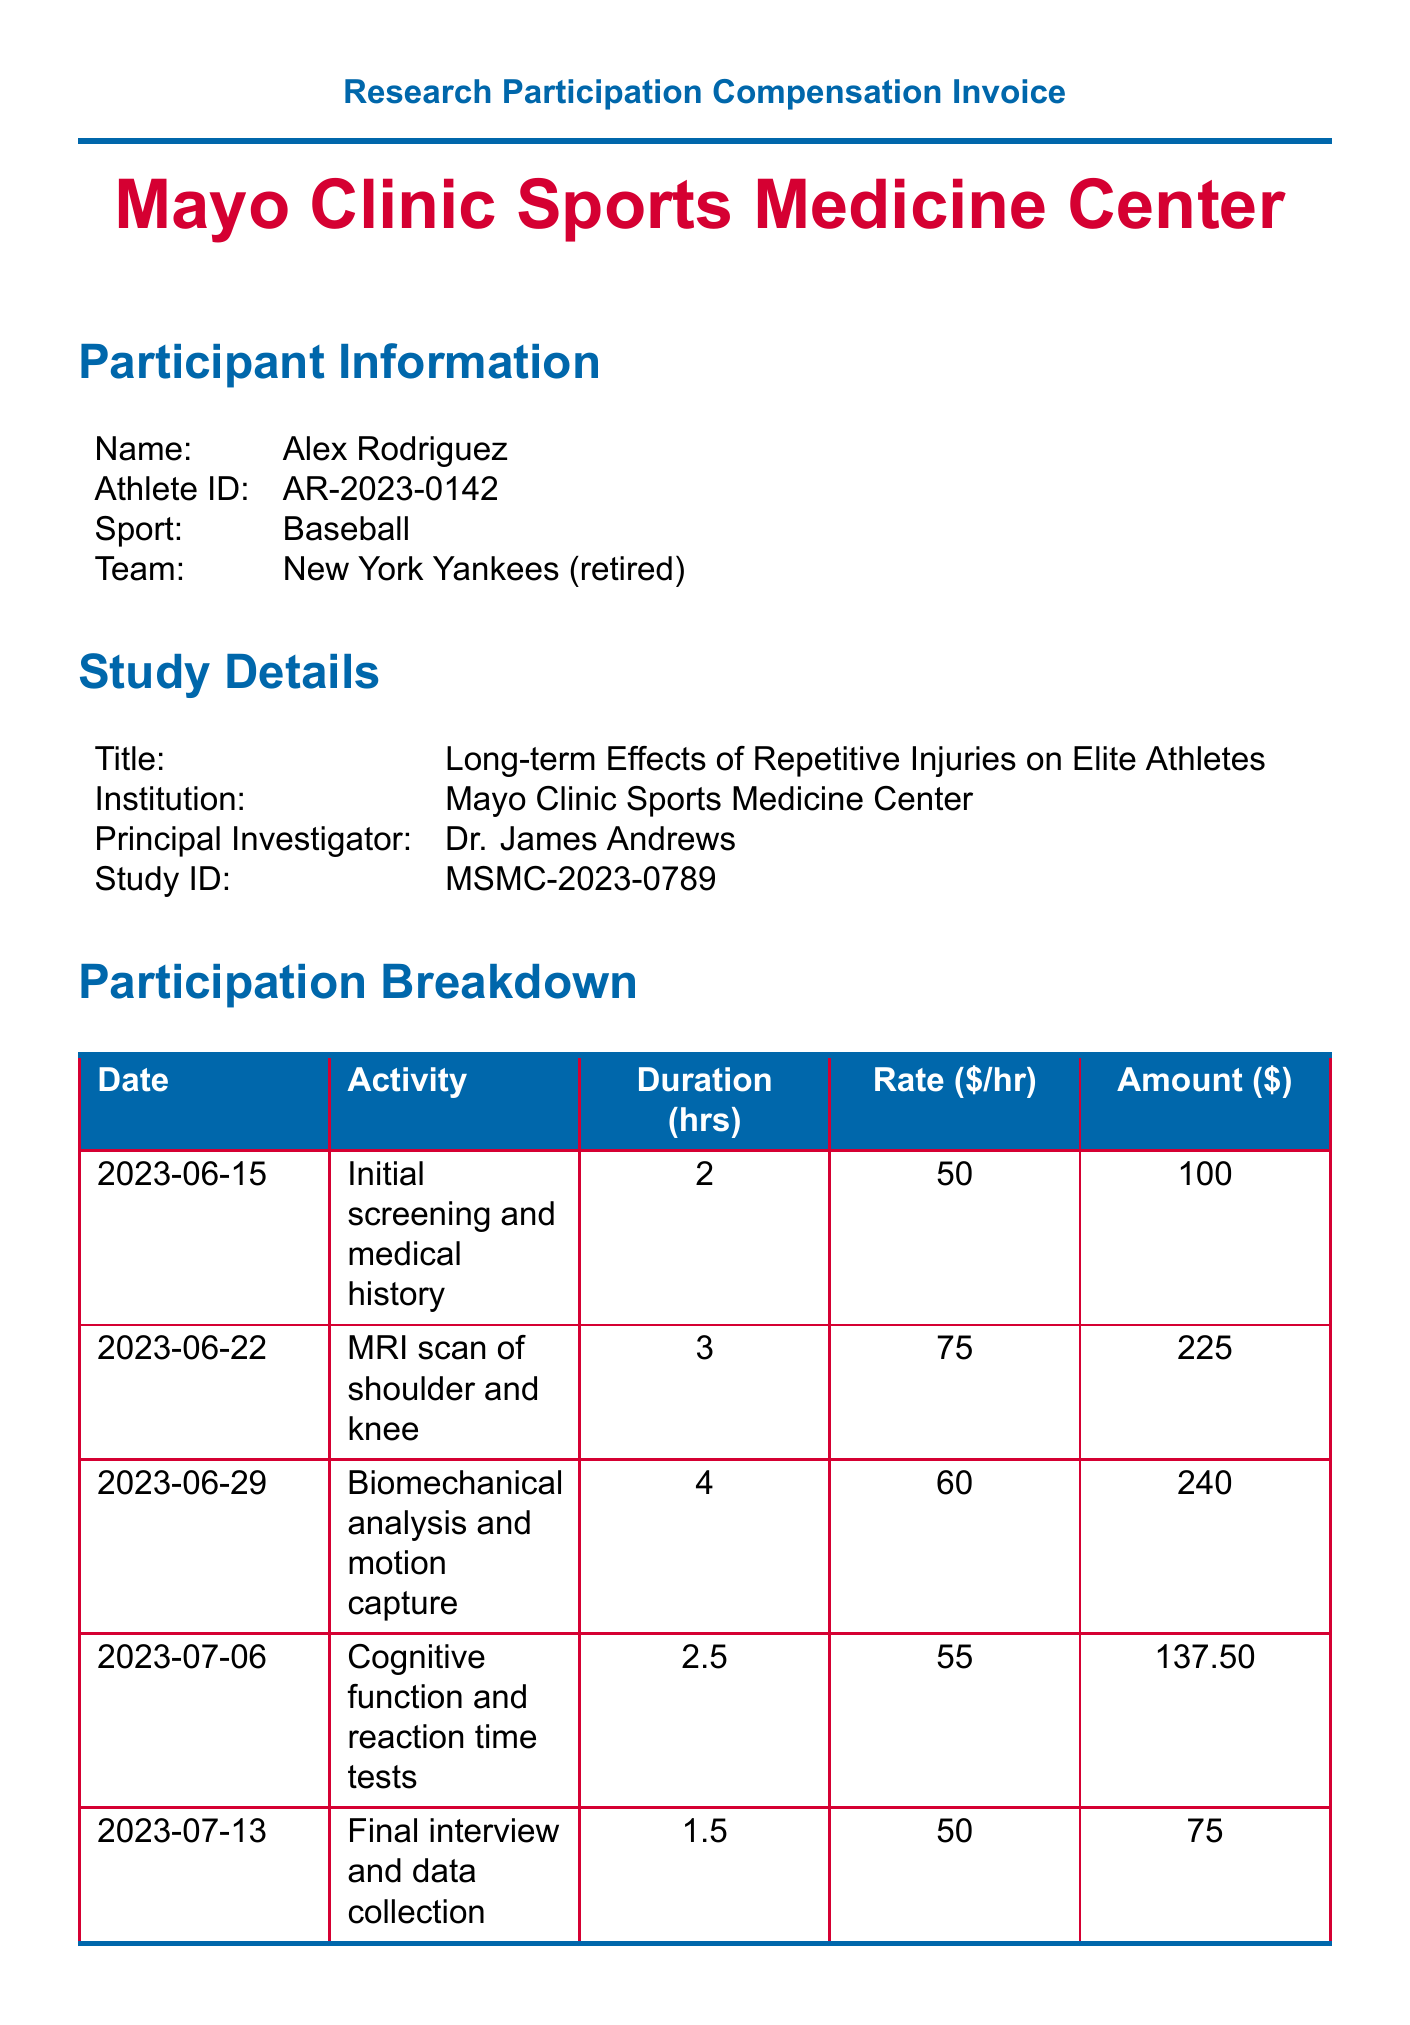What is the participant's name? The participant's name is clearly stated in the participant information section of the document.
Answer: Alex Rodriguez What is the study title? The title of the study is provided in the study details section, which describes the research being conducted.
Answer: Long-term Effects of Repetitive Injuries on Elite Athletes How many hours did the participant spend on the study? The total hours are summarized in the payment summary section of the invoice.
Answer: 13 What was the compensation rate for the MRI scan? The compensation rate for the MRI scan is specifically listed in the participation breakdown for that date and activity.
Answer: 75 What is the total payment amount? The total payment is calculated and provided in the payment summary section, summarizing the compensation and reimbursements.
Answer: 962.50 Who is the principal investigator? The principal investigator's name is included in the study details, indicating who is leading the research project.
Answer: Dr. James Andrews What was the date of the final interview? The date of the final interview can be found in the participation breakdown, detailing when each activity occurred.
Answer: 2023-07-13 What is the amount for travel reimbursement? The specific amount for travel reimbursement is mentioned in the additional compensation section of the invoice.
Answer: 150 What is the payment method indicated for the compensation? The payment method is stated in the payment summary section, specifying how the payment will be made.
Answer: Direct deposit 